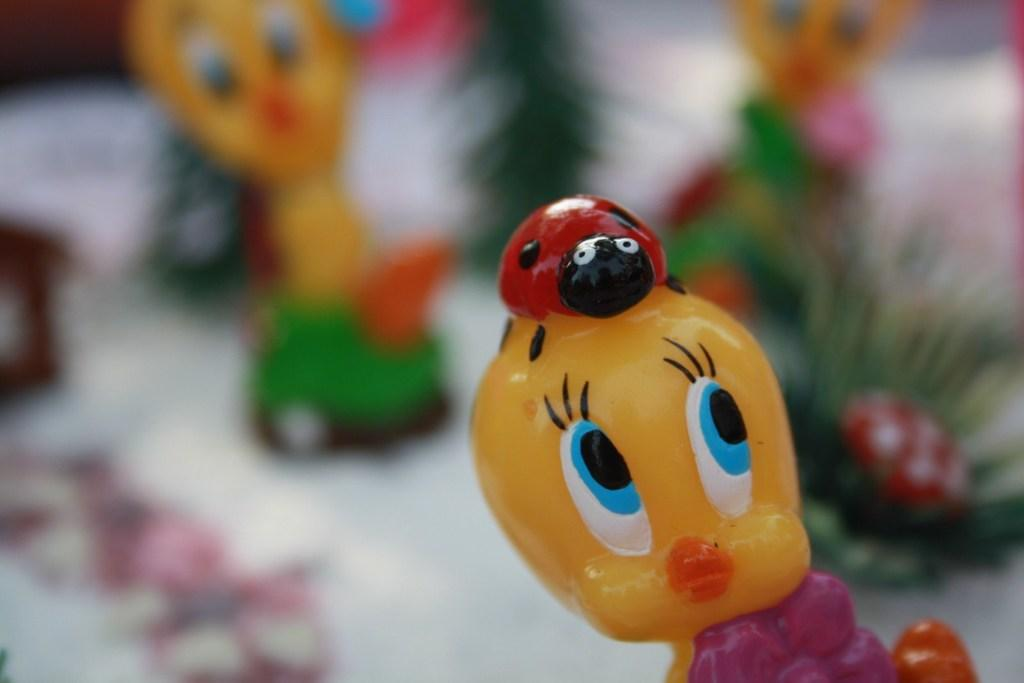What objects can be seen in the image? There are toys in the image. Can you describe the background of the image? The background of the image is blurry. Where is the brother sitting in the image? There is no brother present in the image; it only features toys. What type of patch can be seen on the pan in the image? There is no pan or patch present in the image. 